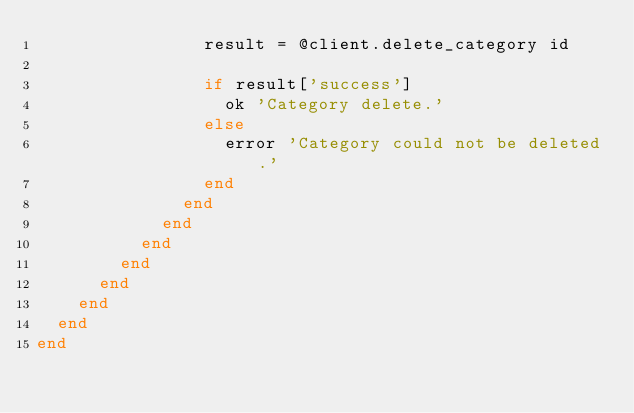Convert code to text. <code><loc_0><loc_0><loc_500><loc_500><_Ruby_>                result = @client.delete_category id

                if result['success']
                  ok 'Category delete.'
                else
                  error 'Category could not be deleted.'
                end
              end
            end
          end
        end
      end
    end
  end
end</code> 